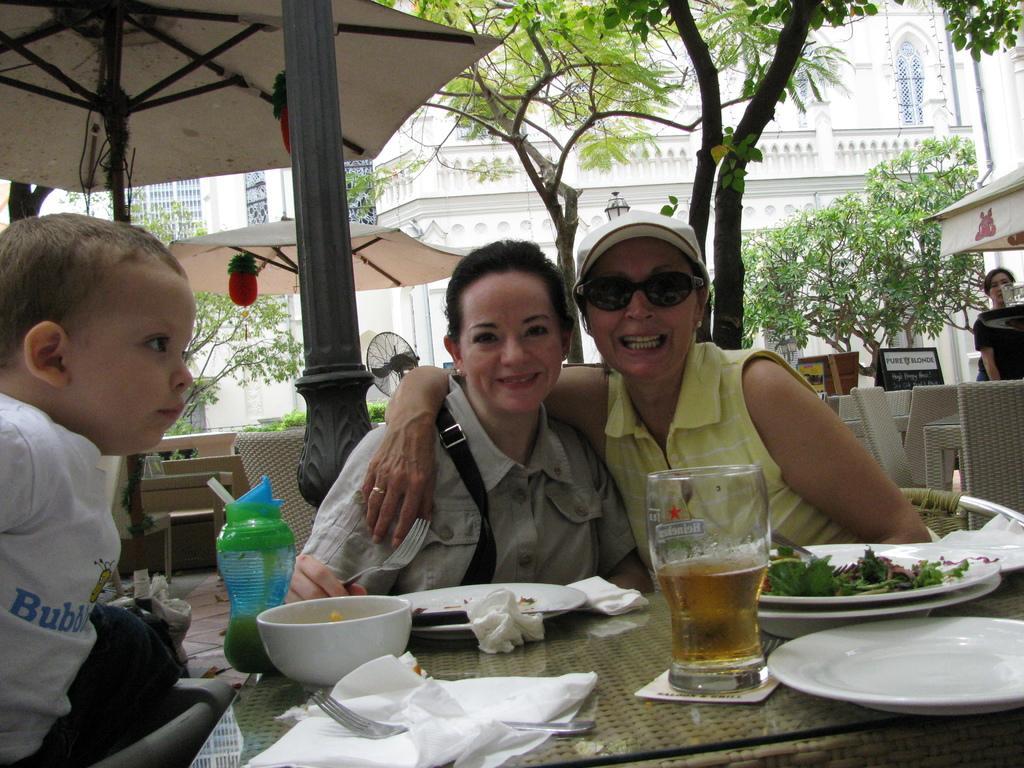Could you give a brief overview of what you see in this image? In this image I see 2 women and both of them are smiling. I can also see that there is a baby over here and there is table in front and lot of things on it. In the background I can see few chairs, few poles, a women, few buildings and trees. 